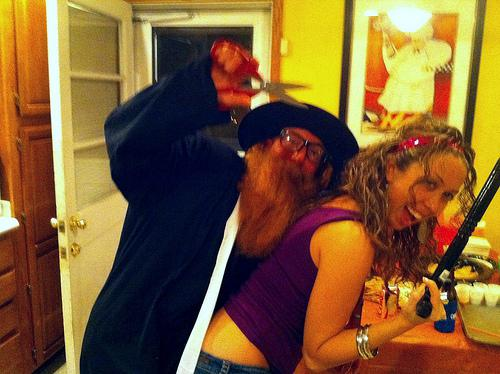Question: when is the picture taken?
Choices:
A. Night time.
B. Day time.
C. Morning.
D. Christmas Day.
Answer with the letter. Answer: A Question: what is the color of the wall?
Choices:
A. Yellow.
B. Blue.
C. Pink.
D. Cream.
Answer with the letter. Answer: A Question: what is the color of the scissors?
Choices:
A. Silver.
B. Red.
C. Black.
D. Green.
Answer with the letter. Answer: B 